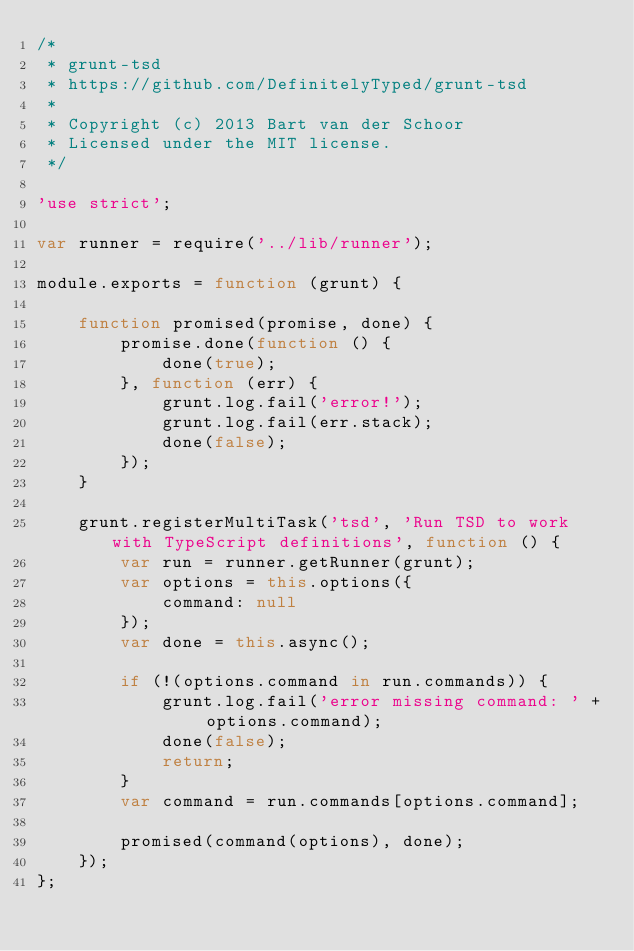<code> <loc_0><loc_0><loc_500><loc_500><_JavaScript_>/*
 * grunt-tsd
 * https://github.com/DefinitelyTyped/grunt-tsd
 *
 * Copyright (c) 2013 Bart van der Schoor
 * Licensed under the MIT license.
 */

'use strict';

var runner = require('../lib/runner');

module.exports = function (grunt) {

	function promised(promise, done) {
		promise.done(function () {
			done(true);
		}, function (err) {
			grunt.log.fail('error!');
			grunt.log.fail(err.stack);
			done(false);
		});
	}

	grunt.registerMultiTask('tsd', 'Run TSD to work with TypeScript definitions', function () {
		var run = runner.getRunner(grunt);
		var options = this.options({
			command: null
		});
		var done = this.async();

		if (!(options.command in run.commands)) {
			grunt.log.fail('error missing command: ' + options.command);
			done(false);
			return;
		}
		var command = run.commands[options.command];

		promised(command(options), done);
	});
};
</code> 